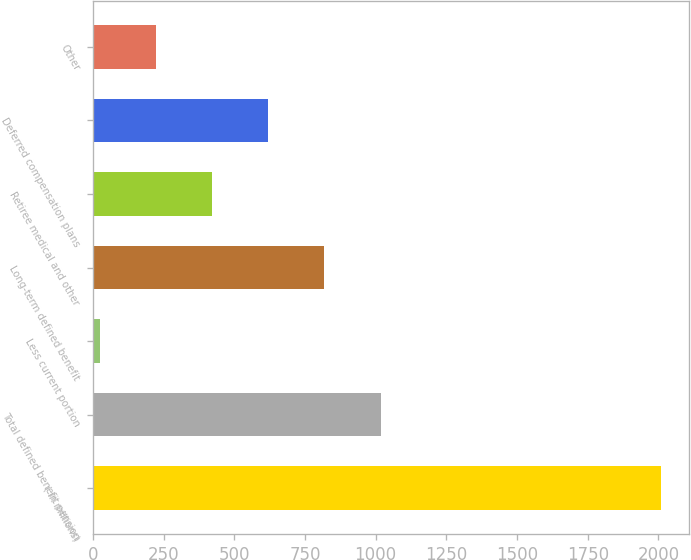Convert chart. <chart><loc_0><loc_0><loc_500><loc_500><bar_chart><fcel>( in millions)<fcel>Total defined benefit pension<fcel>Less current portion<fcel>Long-term defined benefit<fcel>Retiree medical and other<fcel>Deferred compensation plans<fcel>Other<nl><fcel>2009<fcel>1017.4<fcel>25.8<fcel>819.08<fcel>422.44<fcel>620.76<fcel>224.12<nl></chart> 